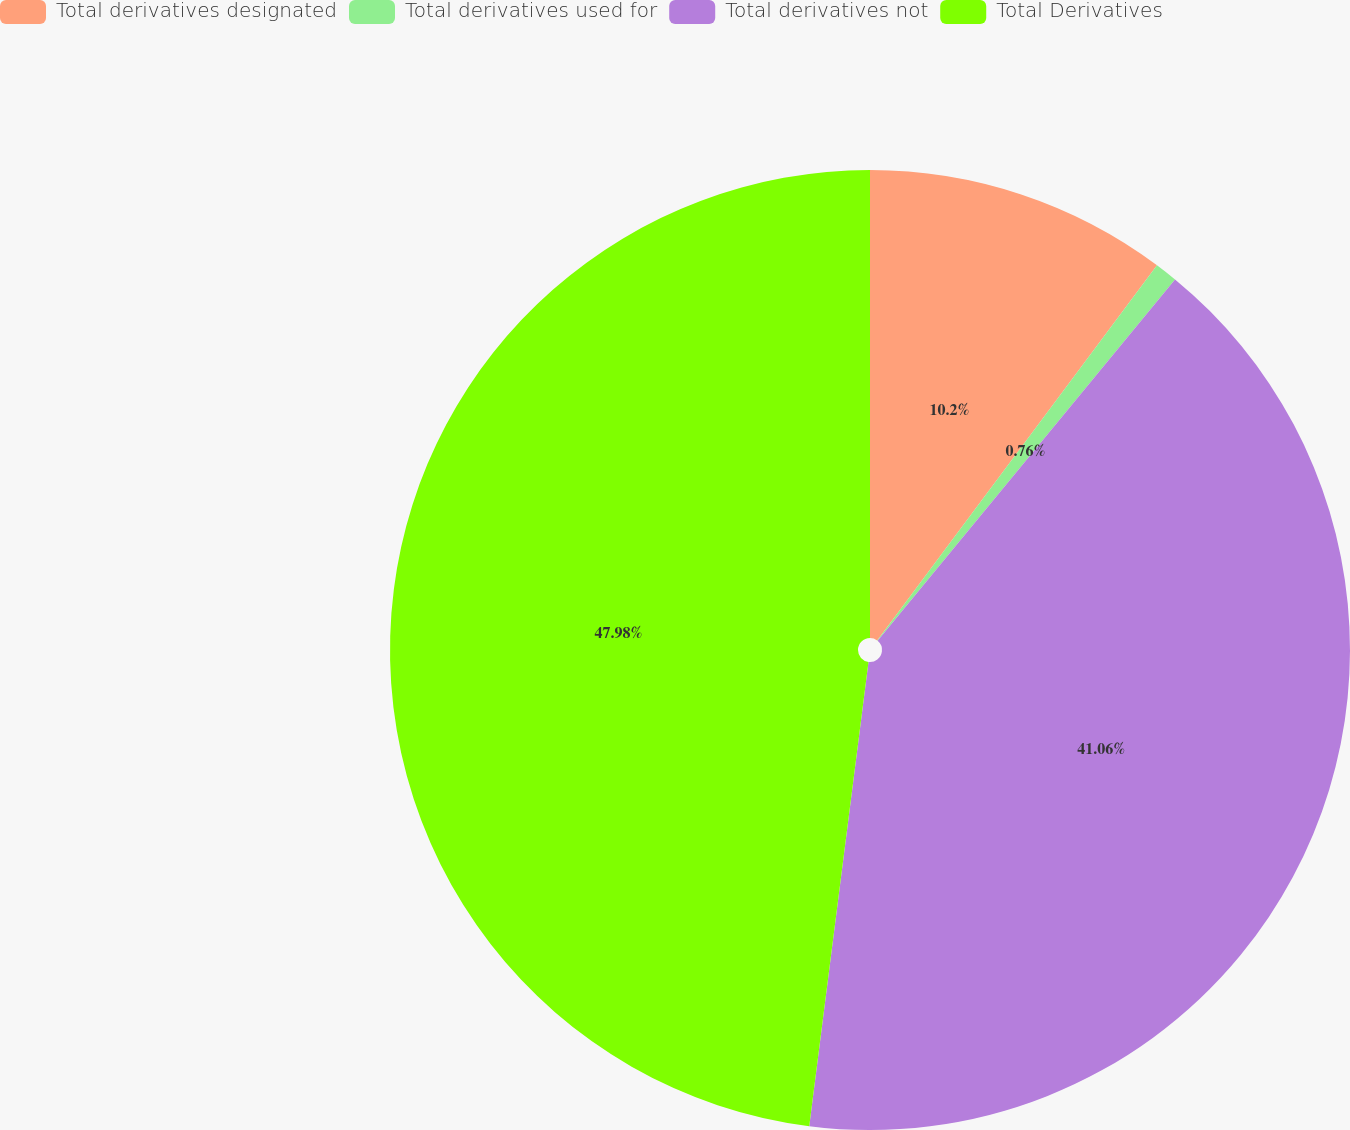Convert chart. <chart><loc_0><loc_0><loc_500><loc_500><pie_chart><fcel>Total derivatives designated<fcel>Total derivatives used for<fcel>Total derivatives not<fcel>Total Derivatives<nl><fcel>10.2%<fcel>0.76%<fcel>41.06%<fcel>47.98%<nl></chart> 